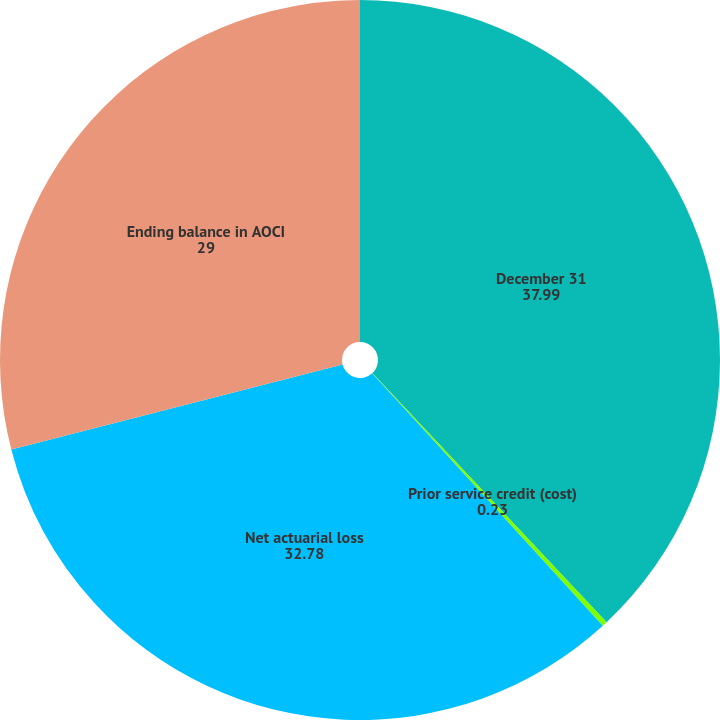<chart> <loc_0><loc_0><loc_500><loc_500><pie_chart><fcel>December 31<fcel>Prior service credit (cost)<fcel>Net actuarial loss<fcel>Ending balance in AOCI<nl><fcel>37.99%<fcel>0.23%<fcel>32.78%<fcel>29.0%<nl></chart> 